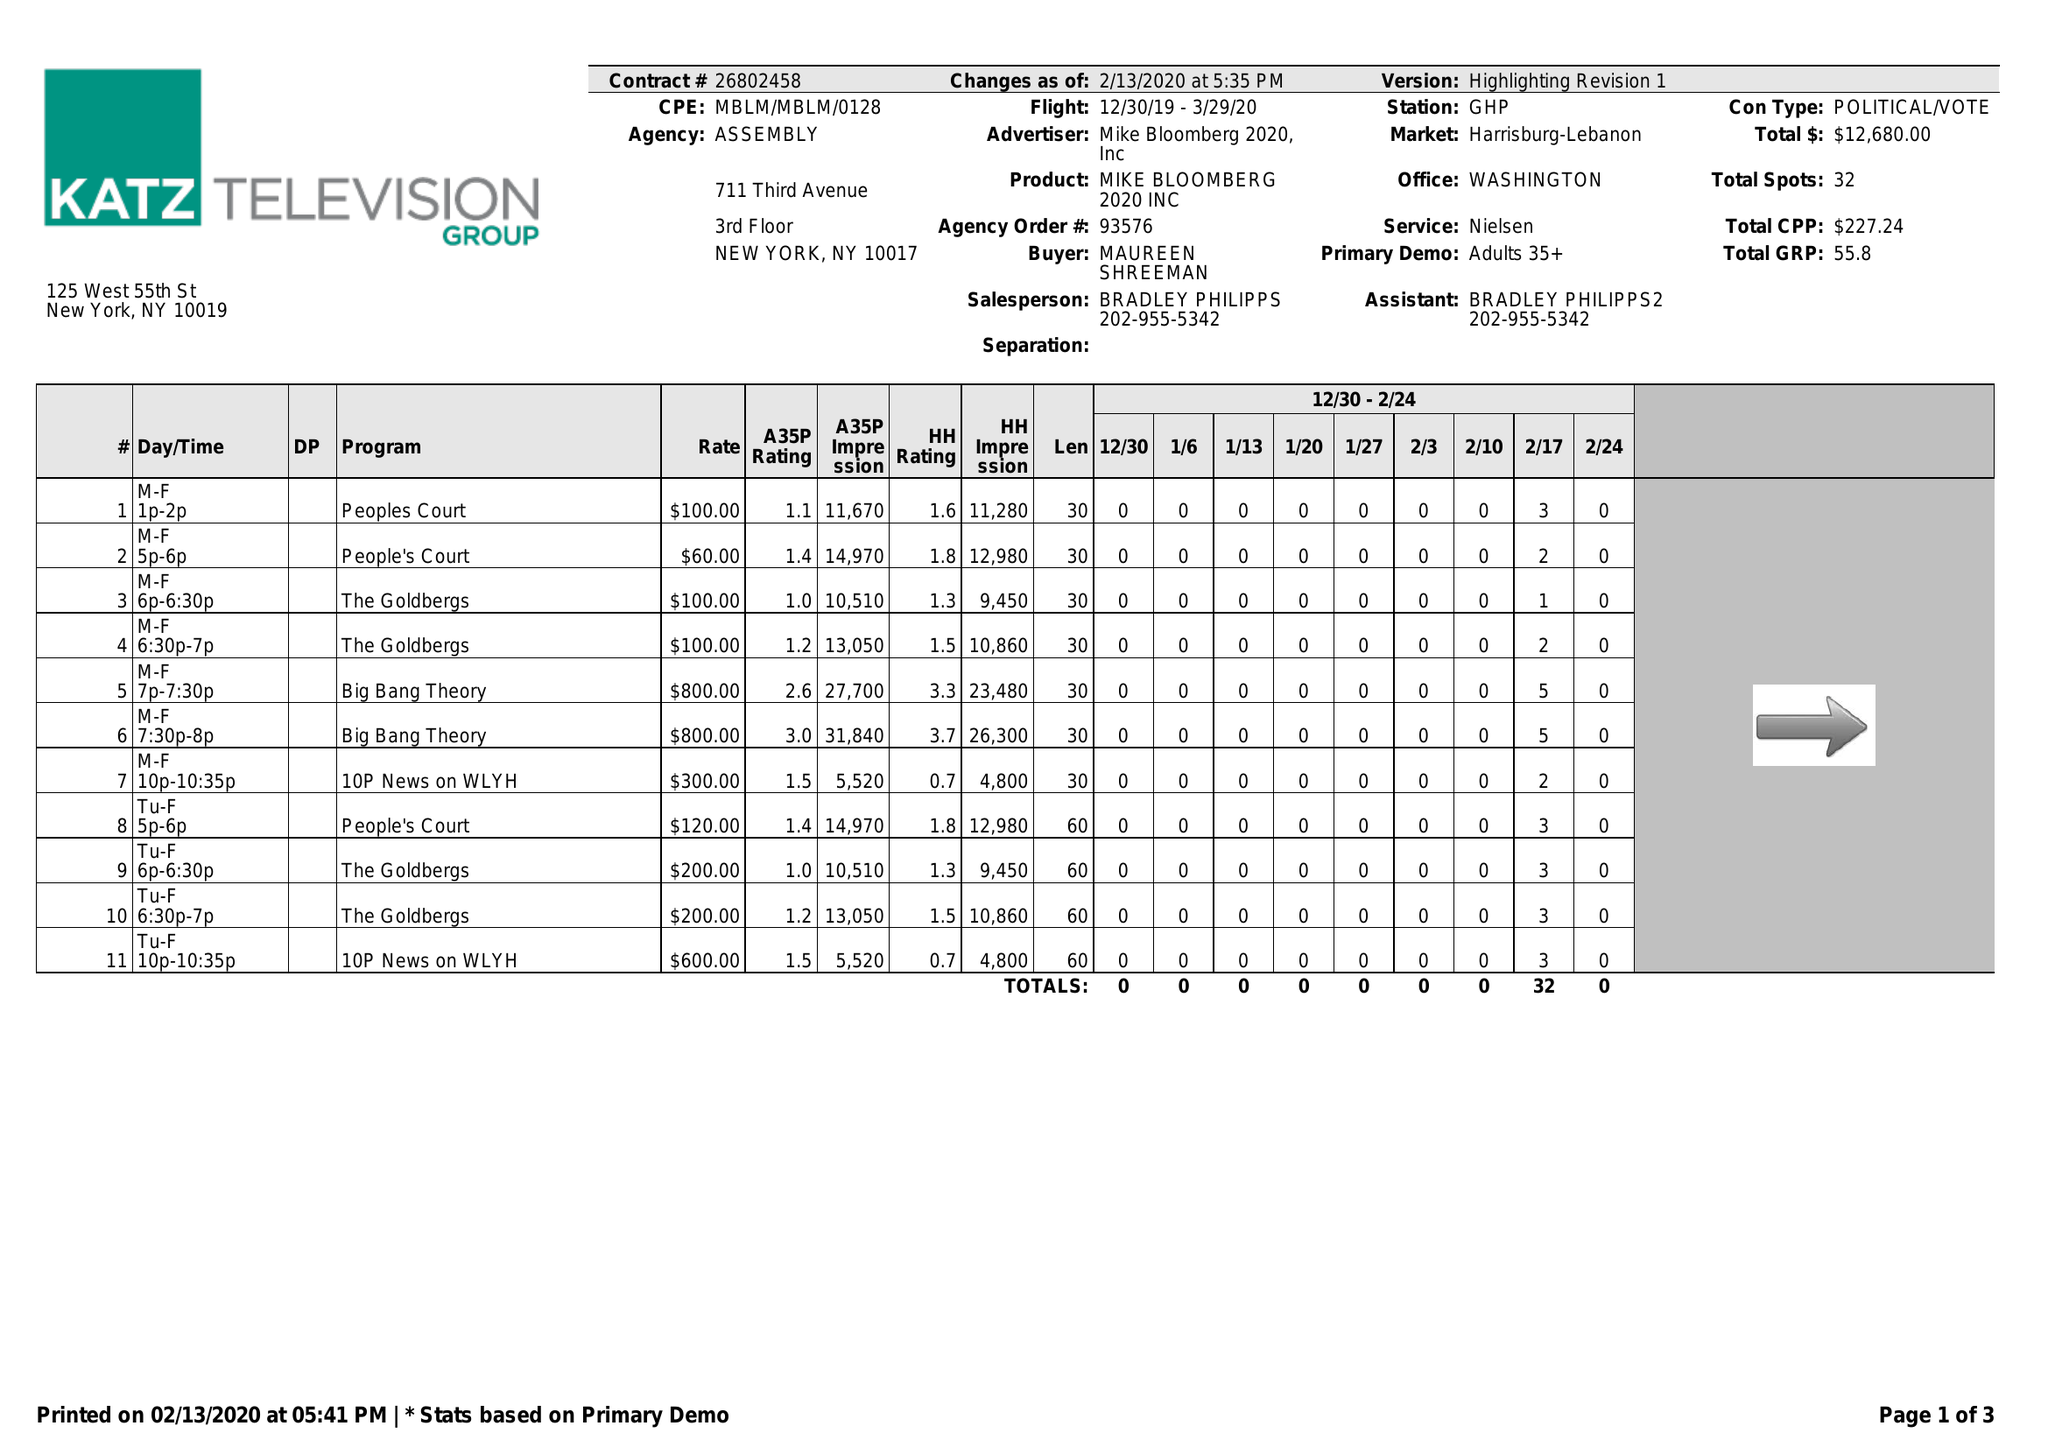What is the value for the contract_num?
Answer the question using a single word or phrase. 26802458 